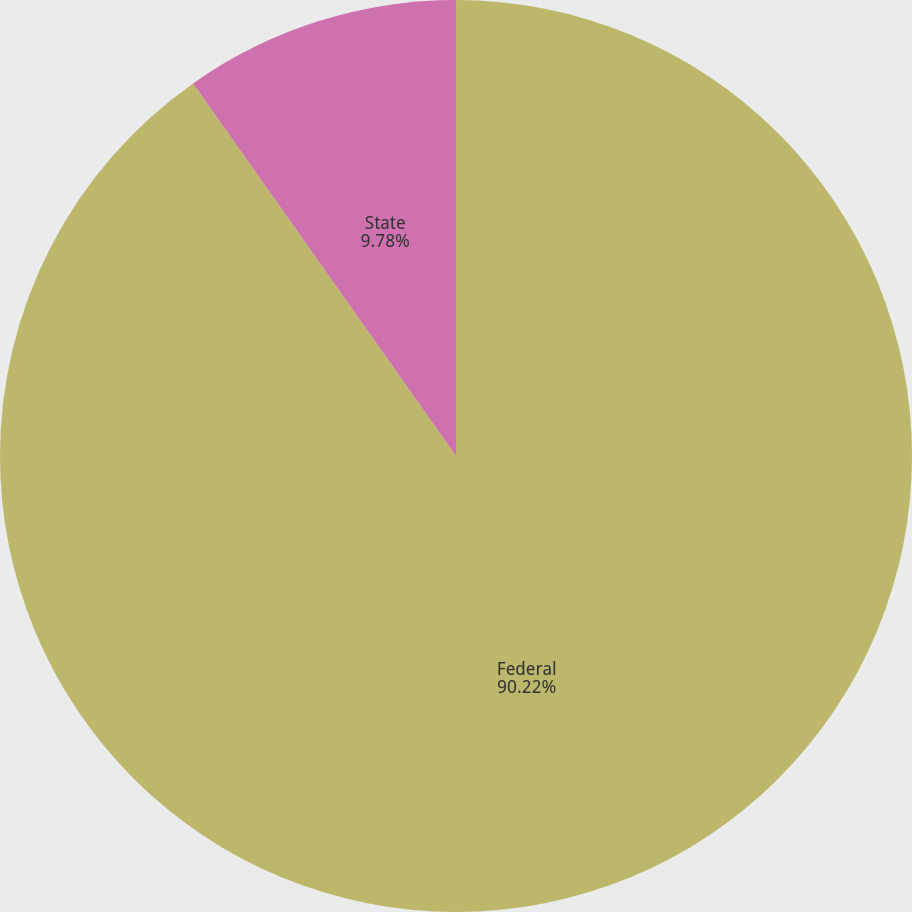Convert chart to OTSL. <chart><loc_0><loc_0><loc_500><loc_500><pie_chart><fcel>Federal<fcel>State<nl><fcel>90.22%<fcel>9.78%<nl></chart> 